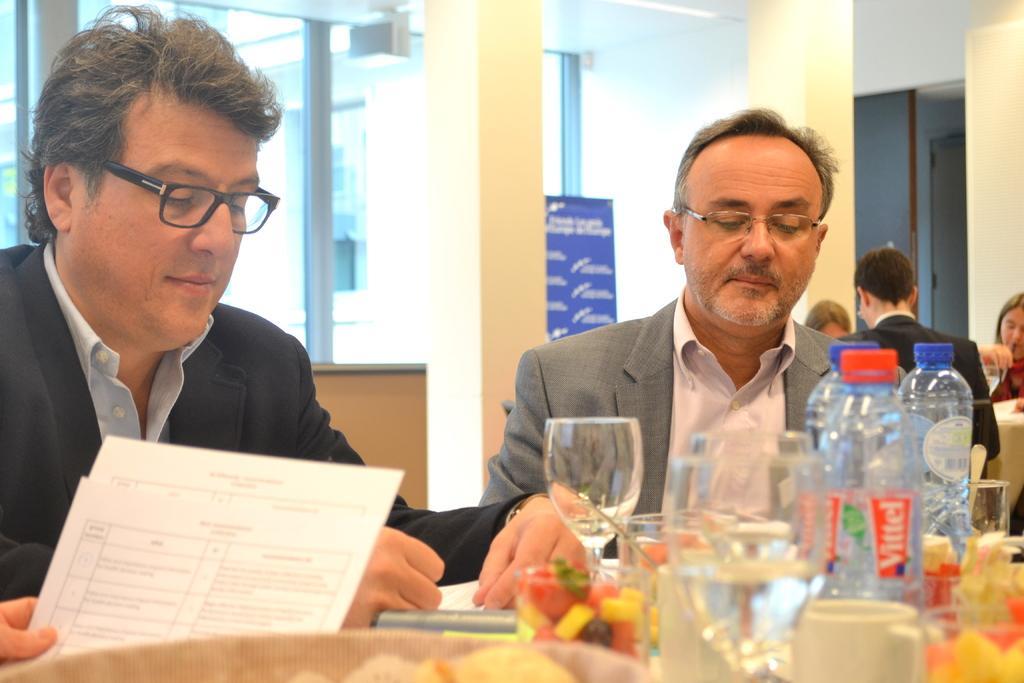Can you describe this image briefly? There are two persons wearing suits and sitting in chair and there is a table in front of them which consists of water bottle,glasses and papers. 